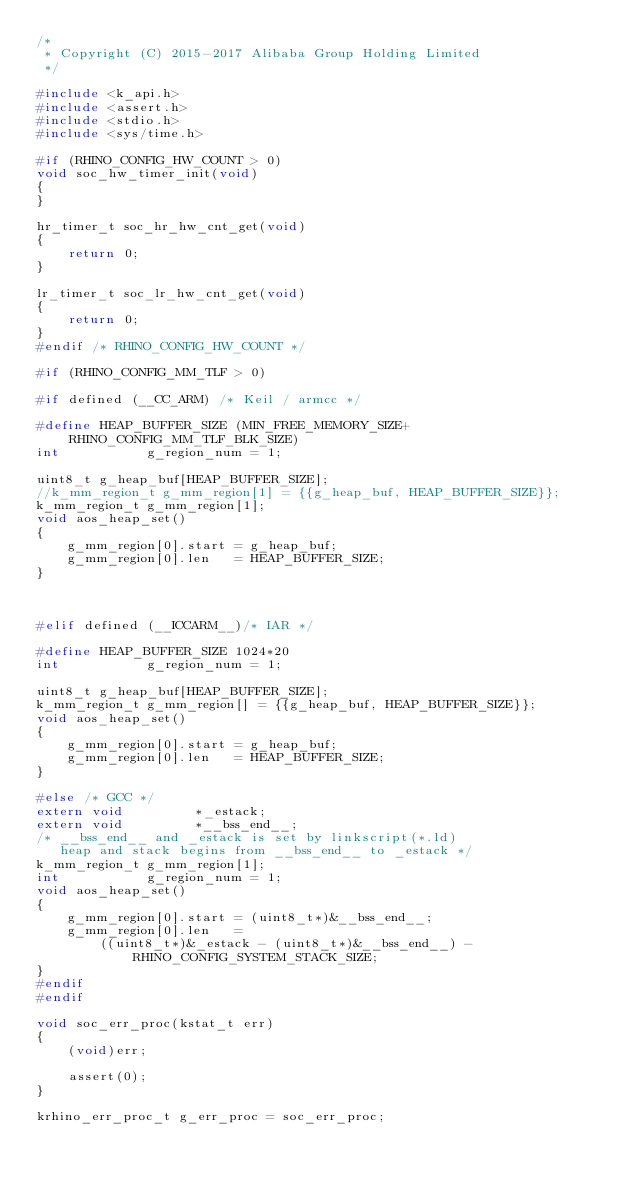<code> <loc_0><loc_0><loc_500><loc_500><_C_>/*
 * Copyright (C) 2015-2017 Alibaba Group Holding Limited
 */

#include <k_api.h>
#include <assert.h>
#include <stdio.h>
#include <sys/time.h>

#if (RHINO_CONFIG_HW_COUNT > 0)
void soc_hw_timer_init(void)
{
}

hr_timer_t soc_hr_hw_cnt_get(void)
{
    return 0;
}

lr_timer_t soc_lr_hw_cnt_get(void)
{
    return 0;
}
#endif /* RHINO_CONFIG_HW_COUNT */

#if (RHINO_CONFIG_MM_TLF > 0)

#if defined (__CC_ARM) /* Keil / armcc */

#define HEAP_BUFFER_SIZE (MIN_FREE_MEMORY_SIZE+RHINO_CONFIG_MM_TLF_BLK_SIZE)
int           g_region_num = 1;

uint8_t g_heap_buf[HEAP_BUFFER_SIZE];
//k_mm_region_t g_mm_region[1] = {{g_heap_buf, HEAP_BUFFER_SIZE}};
k_mm_region_t g_mm_region[1];
void aos_heap_set()
{
    g_mm_region[0].start = g_heap_buf;
    g_mm_region[0].len   = HEAP_BUFFER_SIZE;
}



#elif defined (__ICCARM__)/* IAR */

#define HEAP_BUFFER_SIZE 1024*20
int           g_region_num = 1;

uint8_t g_heap_buf[HEAP_BUFFER_SIZE];
k_mm_region_t g_mm_region[] = {{g_heap_buf, HEAP_BUFFER_SIZE}};
void aos_heap_set()
{
    g_mm_region[0].start = g_heap_buf;
    g_mm_region[0].len   = HEAP_BUFFER_SIZE;
}

#else /* GCC */
extern void         *_estack;
extern void         *__bss_end__;
/* __bss_end__ and _estack is set by linkscript(*.ld)
   heap and stack begins from __bss_end__ to _estack */
k_mm_region_t g_mm_region[1];
int           g_region_num = 1;
void aos_heap_set()
{
    g_mm_region[0].start = (uint8_t*)&__bss_end__;
    g_mm_region[0].len   =
        ((uint8_t*)&_estack - (uint8_t*)&__bss_end__) - RHINO_CONFIG_SYSTEM_STACK_SIZE;
}
#endif
#endif

void soc_err_proc(kstat_t err)
{
    (void)err;

    assert(0);
}

krhino_err_proc_t g_err_proc = soc_err_proc;


</code> 